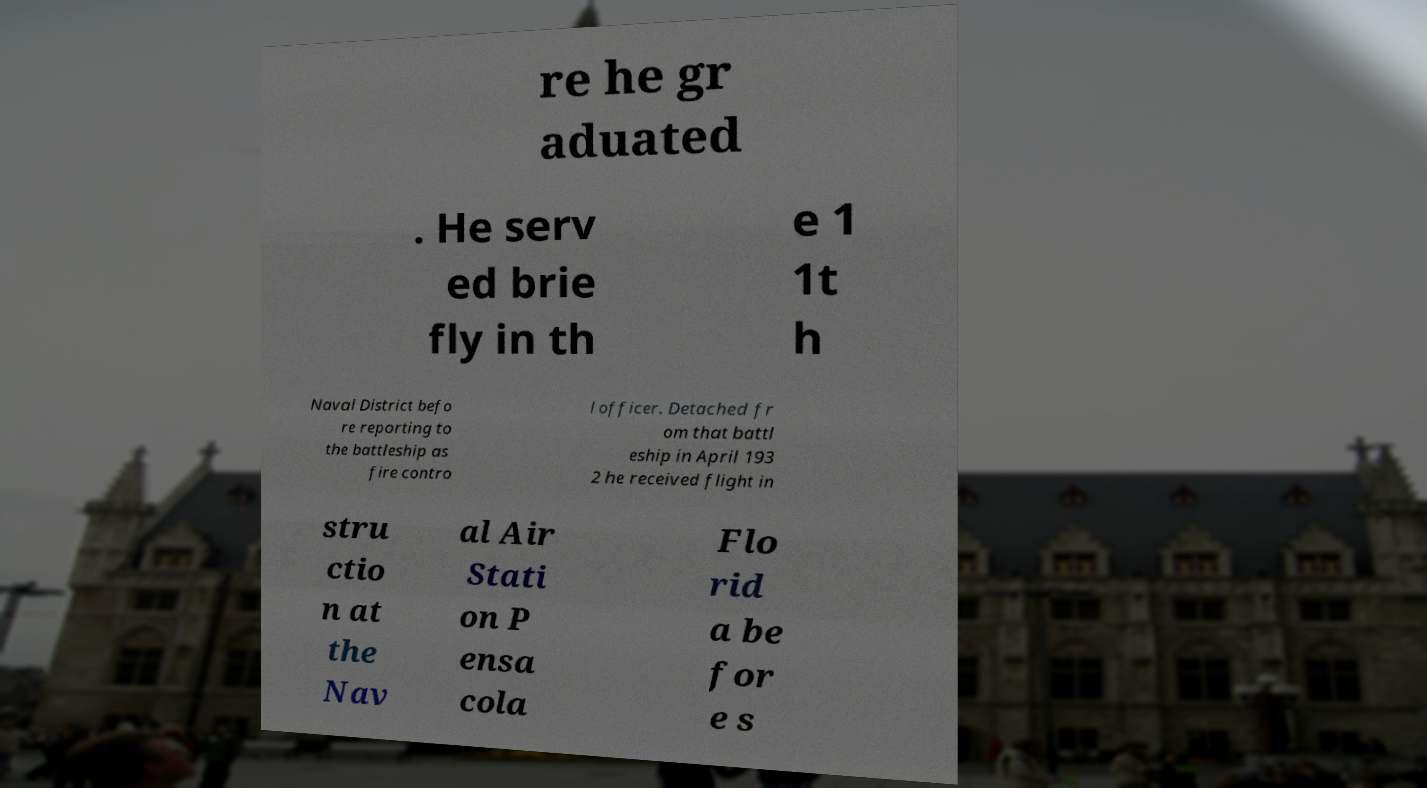What messages or text are displayed in this image? I need them in a readable, typed format. re he gr aduated . He serv ed brie fly in th e 1 1t h Naval District befo re reporting to the battleship as fire contro l officer. Detached fr om that battl eship in April 193 2 he received flight in stru ctio n at the Nav al Air Stati on P ensa cola Flo rid a be for e s 